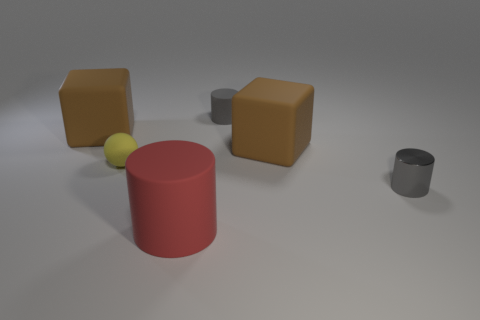What is the color of the big cylinder?
Give a very brief answer. Red. What number of other small gray matte things have the same shape as the gray matte thing?
Your answer should be very brief. 0. What is the color of the rubber cylinder that is the same size as the yellow ball?
Your response must be concise. Gray. Is there a large brown rubber cube?
Your answer should be compact. Yes. What is the shape of the matte thing that is in front of the shiny cylinder?
Your response must be concise. Cylinder. How many large brown rubber cubes are both to the left of the small matte ball and to the right of the large matte cylinder?
Your answer should be very brief. 0. Is there a tiny green sphere made of the same material as the red cylinder?
Provide a succinct answer. No. What number of cylinders are either small things or yellow things?
Your response must be concise. 2. The red matte thing has what size?
Give a very brief answer. Large. How many cylinders are left of the gray matte cylinder?
Your answer should be very brief. 1. 